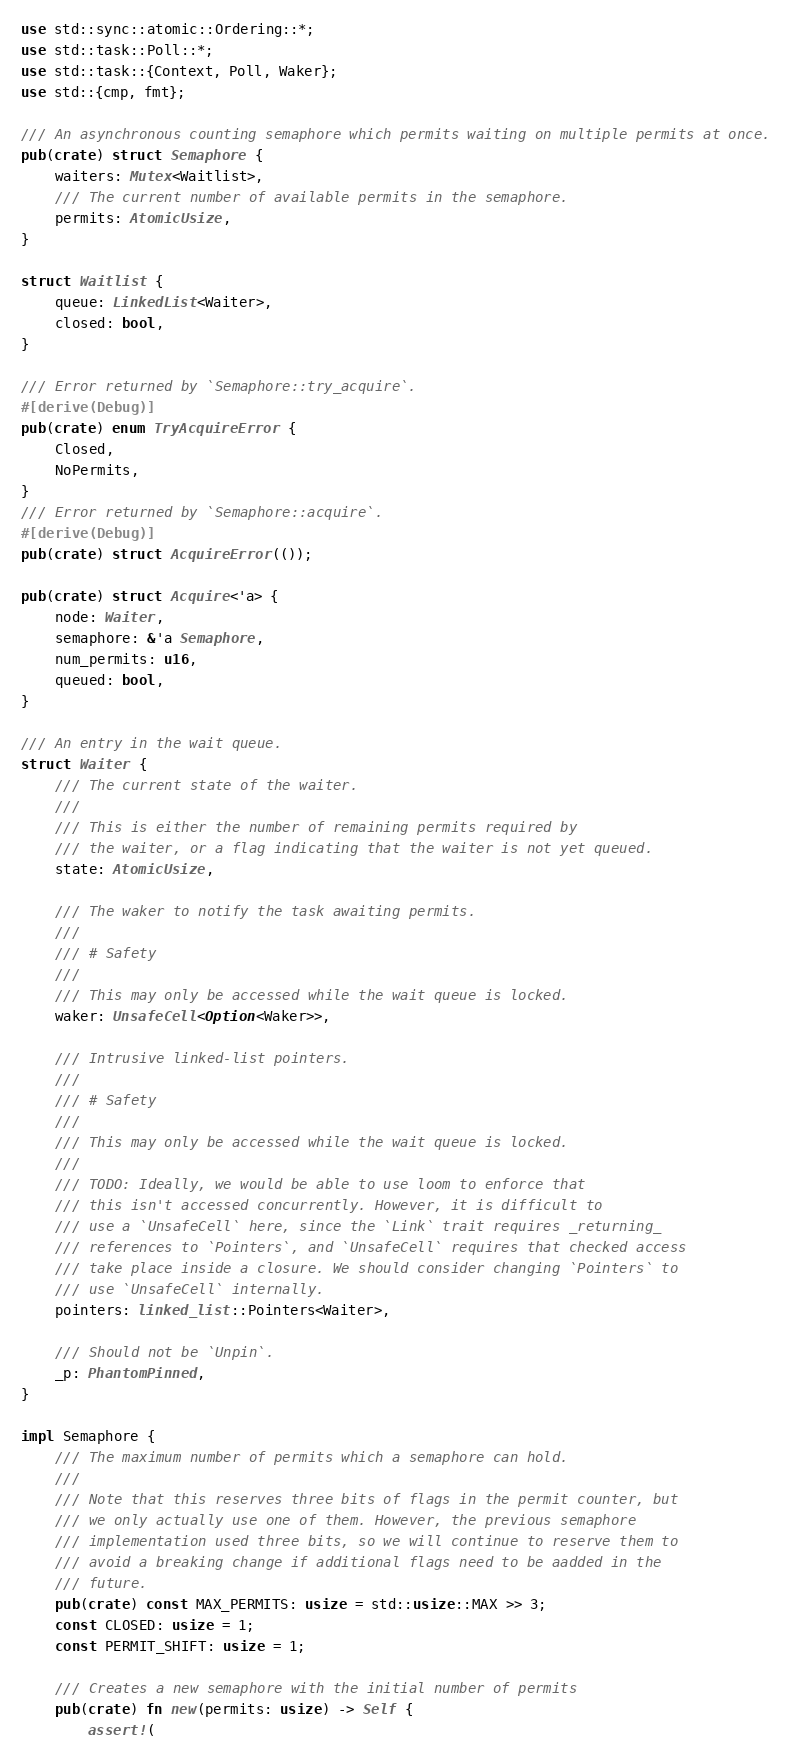<code> <loc_0><loc_0><loc_500><loc_500><_Rust_>use std::sync::atomic::Ordering::*;
use std::task::Poll::*;
use std::task::{Context, Poll, Waker};
use std::{cmp, fmt};

/// An asynchronous counting semaphore which permits waiting on multiple permits at once.
pub(crate) struct Semaphore {
    waiters: Mutex<Waitlist>,
    /// The current number of available permits in the semaphore.
    permits: AtomicUsize,
}

struct Waitlist {
    queue: LinkedList<Waiter>,
    closed: bool,
}

/// Error returned by `Semaphore::try_acquire`.
#[derive(Debug)]
pub(crate) enum TryAcquireError {
    Closed,
    NoPermits,
}
/// Error returned by `Semaphore::acquire`.
#[derive(Debug)]
pub(crate) struct AcquireError(());

pub(crate) struct Acquire<'a> {
    node: Waiter,
    semaphore: &'a Semaphore,
    num_permits: u16,
    queued: bool,
}

/// An entry in the wait queue.
struct Waiter {
    /// The current state of the waiter.
    ///
    /// This is either the number of remaining permits required by
    /// the waiter, or a flag indicating that the waiter is not yet queued.
    state: AtomicUsize,

    /// The waker to notify the task awaiting permits.
    ///
    /// # Safety
    ///
    /// This may only be accessed while the wait queue is locked.
    waker: UnsafeCell<Option<Waker>>,

    /// Intrusive linked-list pointers.
    ///
    /// # Safety
    ///
    /// This may only be accessed while the wait queue is locked.
    ///
    /// TODO: Ideally, we would be able to use loom to enforce that
    /// this isn't accessed concurrently. However, it is difficult to
    /// use a `UnsafeCell` here, since the `Link` trait requires _returning_
    /// references to `Pointers`, and `UnsafeCell` requires that checked access
    /// take place inside a closure. We should consider changing `Pointers` to
    /// use `UnsafeCell` internally.
    pointers: linked_list::Pointers<Waiter>,

    /// Should not be `Unpin`.
    _p: PhantomPinned,
}

impl Semaphore {
    /// The maximum number of permits which a semaphore can hold.
    ///
    /// Note that this reserves three bits of flags in the permit counter, but
    /// we only actually use one of them. However, the previous semaphore
    /// implementation used three bits, so we will continue to reserve them to
    /// avoid a breaking change if additional flags need to be aadded in the
    /// future.
    pub(crate) const MAX_PERMITS: usize = std::usize::MAX >> 3;
    const CLOSED: usize = 1;
    const PERMIT_SHIFT: usize = 1;

    /// Creates a new semaphore with the initial number of permits
    pub(crate) fn new(permits: usize) -> Self {
        assert!(</code> 